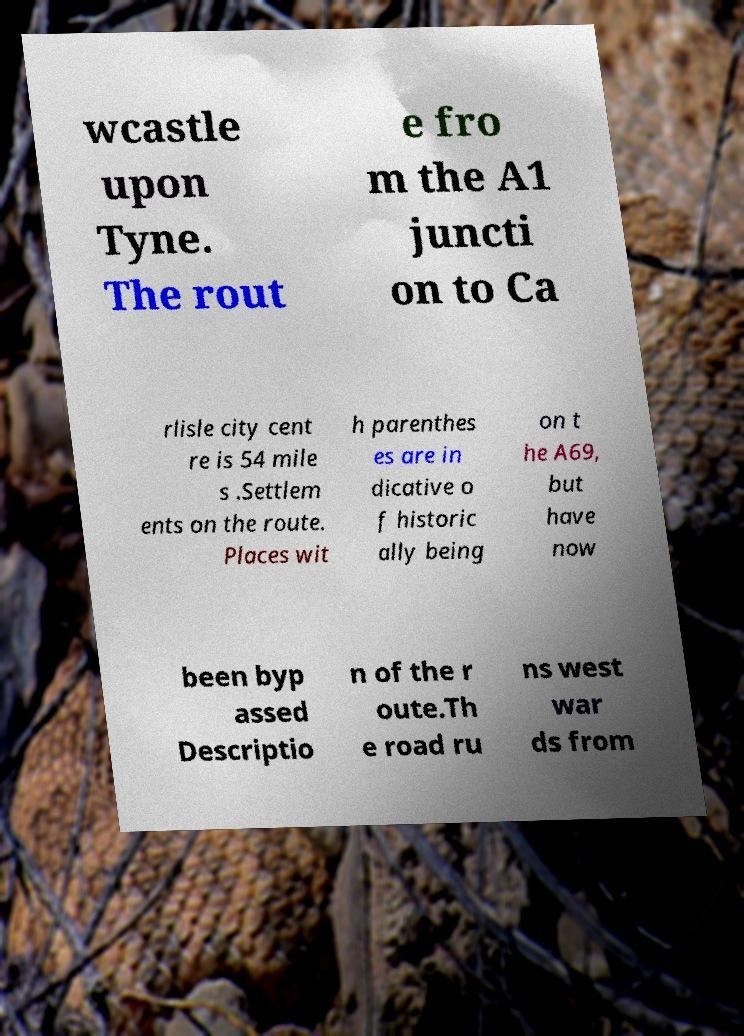Could you extract and type out the text from this image? wcastle upon Tyne. The rout e fro m the A1 juncti on to Ca rlisle city cent re is 54 mile s .Settlem ents on the route. Places wit h parenthes es are in dicative o f historic ally being on t he A69, but have now been byp assed Descriptio n of the r oute.Th e road ru ns west war ds from 